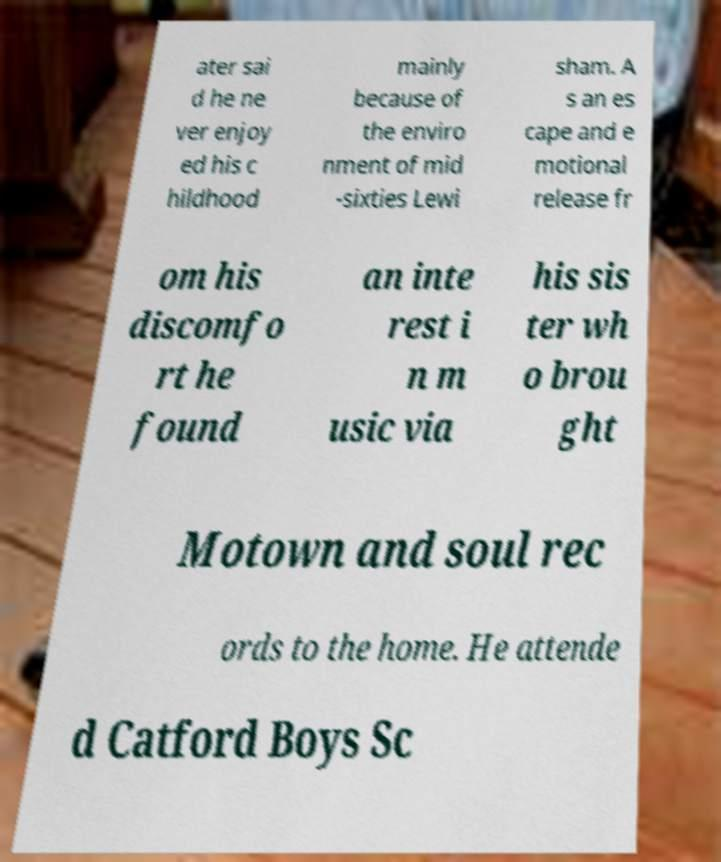There's text embedded in this image that I need extracted. Can you transcribe it verbatim? ater sai d he ne ver enjoy ed his c hildhood mainly because of the enviro nment of mid -sixties Lewi sham. A s an es cape and e motional release fr om his discomfo rt he found an inte rest i n m usic via his sis ter wh o brou ght Motown and soul rec ords to the home. He attende d Catford Boys Sc 